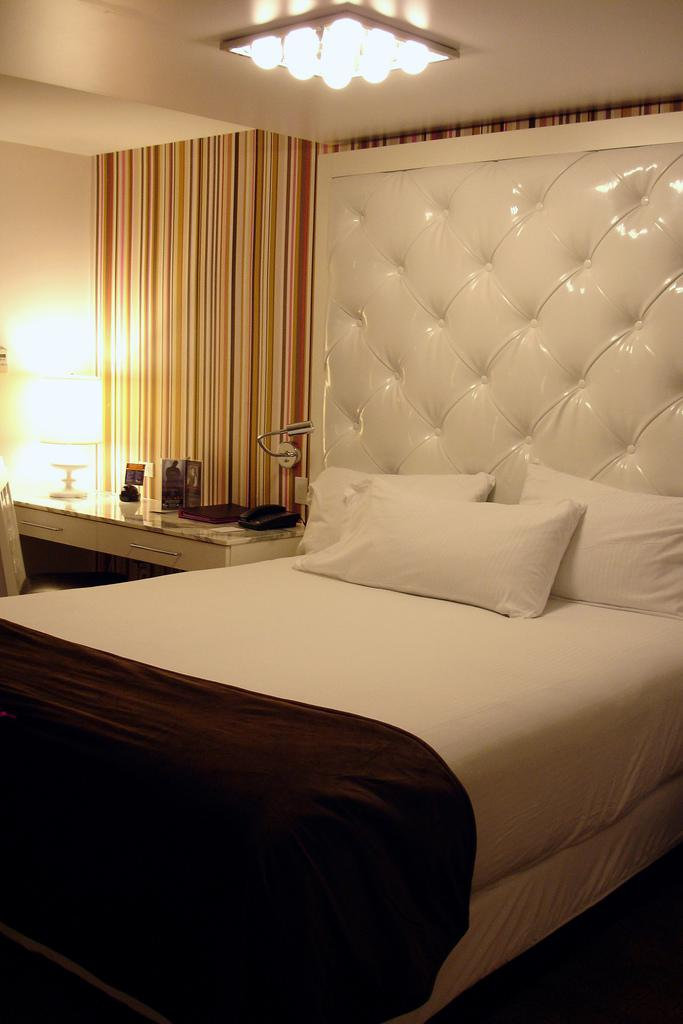Question: who is in this picture?
Choices:
A. Her mother.
B. No one.
C. The kids.
D. The family.
Answer with the letter. Answer: B Question: how many pillows are on the bed?
Choices:
A. Four.
B. Two.
C. Three.
D. One.
Answer with the letter. Answer: C Question: what is on the ceiling?
Choices:
A. A bug.
B. A fan.
C. A fly.
D. Lights.
Answer with the letter. Answer: D Question: what does the bed have on it?
Choices:
A. Sheets.
B. White linens.
C. Many pillows.
D. Cats.
Answer with the letter. Answer: B Question: how many pillows are on the bed?
Choices:
A. Two.
B. One.
C. Three.
D. None.
Answer with the letter. Answer: C Question: what does the other head light have?
Choices:
A. Several bulbs.
B. A broken bulb.
C. A blue bulb.
D. A blinker.
Answer with the letter. Answer: A Question: what kind of bedroom is it?
Choices:
A. A dirty one.
B. A child's room.
C. Clean and nice.
D. A nursery.
Answer with the letter. Answer: C Question: what is next to the bed?
Choices:
A. A teddy bear.
B. A phone.
C. A train track.
D. A rug.
Answer with the letter. Answer: B Question: what is on the desk?
Choices:
A. Homework.
B. A light.
C. A notebook.
D. A laptop.
Answer with the letter. Answer: B Question: what color is the blanket on the bed?
Choices:
A. Tan.
B. Brown.
C. Taupe.
D. Beige.
Answer with the letter. Answer: B Question: how big is the headboard?
Choices:
A. Large.
B. Big.
C. Oversized.
D. Enormous.
Answer with the letter. Answer: C Question: how is the bedspread positioned?
Choices:
A. Messy.
B. Comfortable.
C. Not tight.
D. Turned down.
Answer with the letter. Answer: D Question: where are the different colored stripes?
Choices:
A. On the wall.
B. On the bed spread.
C. In the closet.
D. On a flag.
Answer with the letter. Answer: A Question: what pattern is on the wall?
Choices:
A. Floral.
B. Squares.
C. Triangles.
D. Stripes.
Answer with the letter. Answer: D Question: how is the power of the lamp?
Choices:
A. It is off.
B. It is on.
C. It is unplugged.
D. It is broken.
Answer with the letter. Answer: B Question: what pattern is in the drapes?
Choices:
A. They are checkered.
B. They are solid colors.
C. They are striped.
D. They are tie dyed.
Answer with the letter. Answer: C 